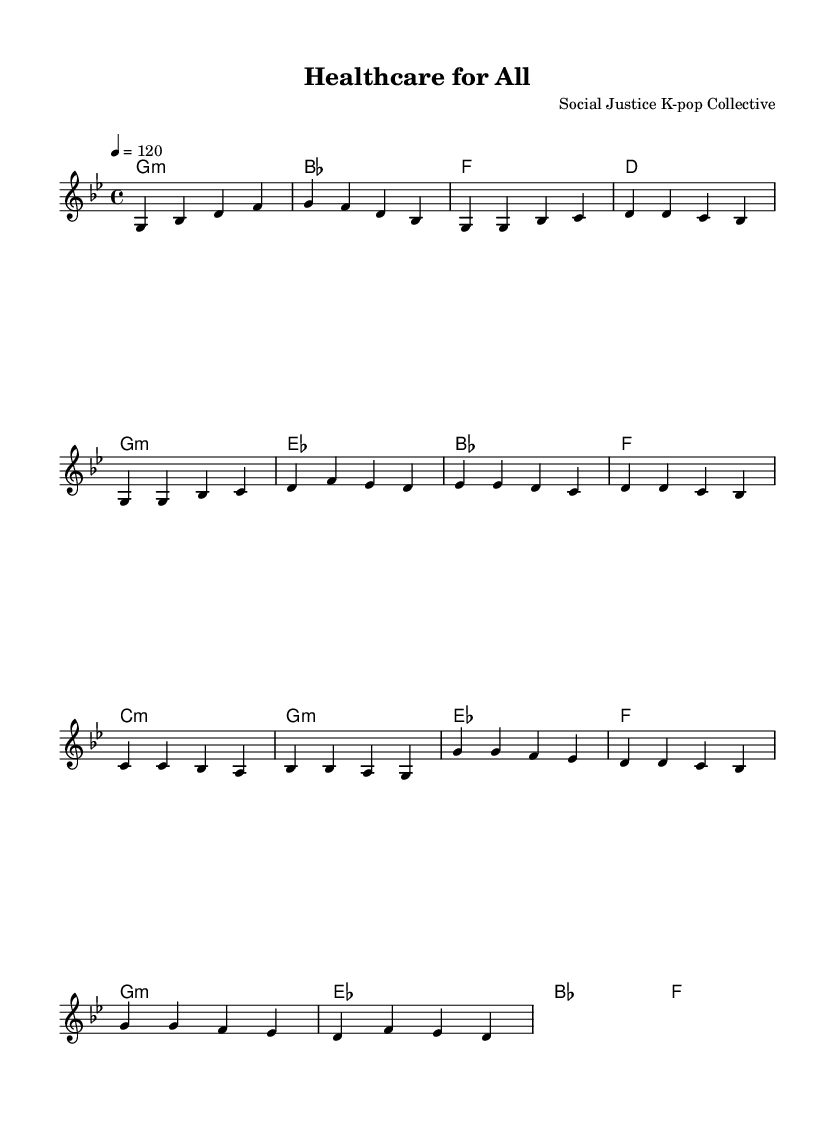What is the key signature of this music? The key signature is indicated by the key signature symbol at the beginning of the staff. Here, it shows B-flat and E-flat, which indicates it's in G minor.
Answer: G minor What is the time signature of this music? The time signature is displayed at the beginning of the score as a fraction, which shows how many beats are in each measure. Here, it shows a 4 on top and a 4 on the bottom, indicating 4 beats per measure.
Answer: 4/4 What is the tempo marking of this piece? The tempo marking is found at the beginning, typically written in beats per minute (BPM). In this case, it shows that the music should be played at 120 beats per minute.
Answer: 120 How many measures are in the verse section? To find the number of measures, count the measures from the score labeled as the "Verse". There are a total of 8 measures in the verse section.
Answer: 8 What chord is used during the pre-chorus? To identify the chord in the pre-chorus, look at the chord names written above the staff during the marked section. The first chord is C minor, which appears there.
Answer: C minor What is the function of the chorus in K-pop music structure? In K-pop, the chorus typically serves the purpose of capturing the main message or hook of the song, usually being the most memorable part. Here, the repetitive and melodic nature of the chorus embodies that characteristic, making it stick with listeners.
Answer: Main hook 